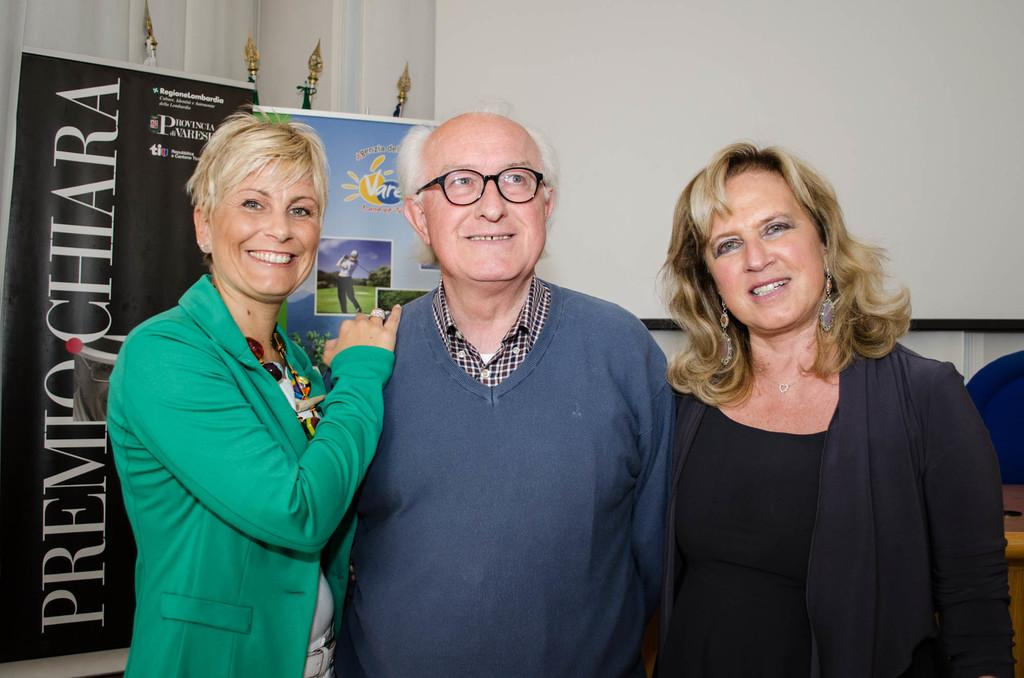What are the people in the image doing? The people in the image are standing and smiling. Can you describe the mood or atmosphere in the image? The mood in the image appears to be positive, as the people are smiling. What can be seen in the background of the image? There are banners and objects in the background of the image. What news is being reported on the doll in the image? There is no doll present in the image, and therefore no news can be reported on it. 